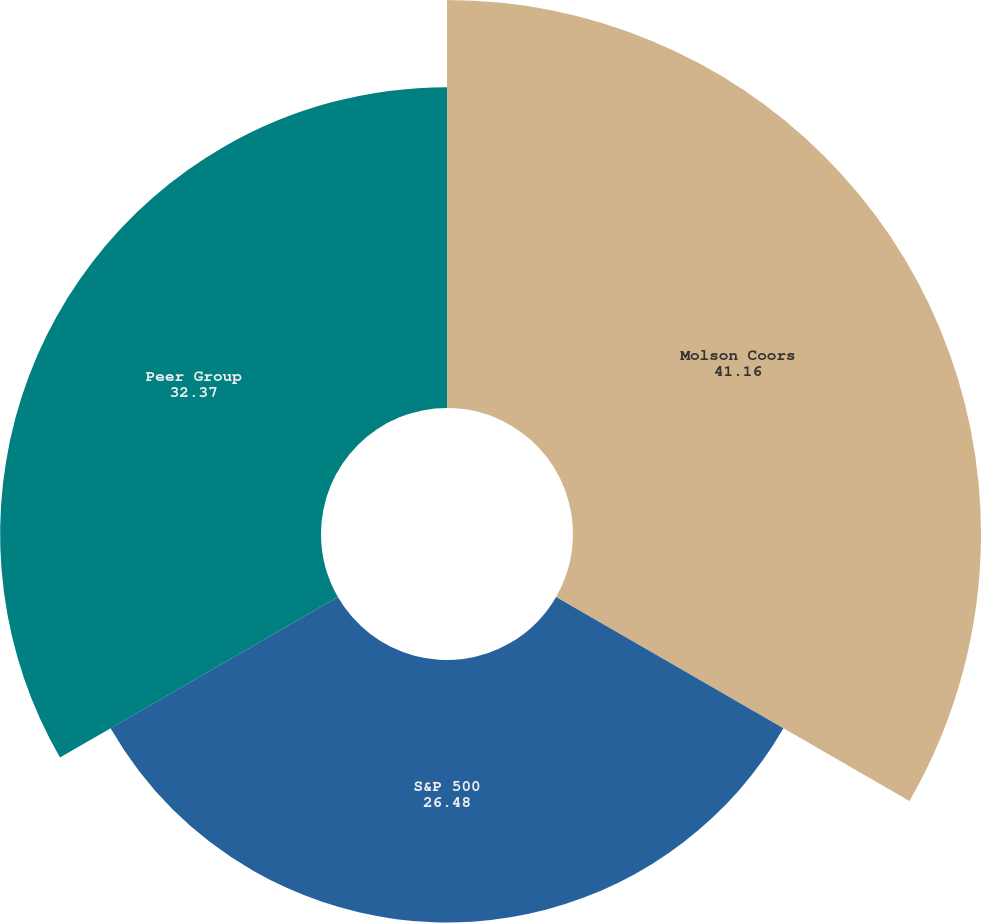Convert chart. <chart><loc_0><loc_0><loc_500><loc_500><pie_chart><fcel>Molson Coors<fcel>S&P 500<fcel>Peer Group<nl><fcel>41.16%<fcel>26.48%<fcel>32.37%<nl></chart> 